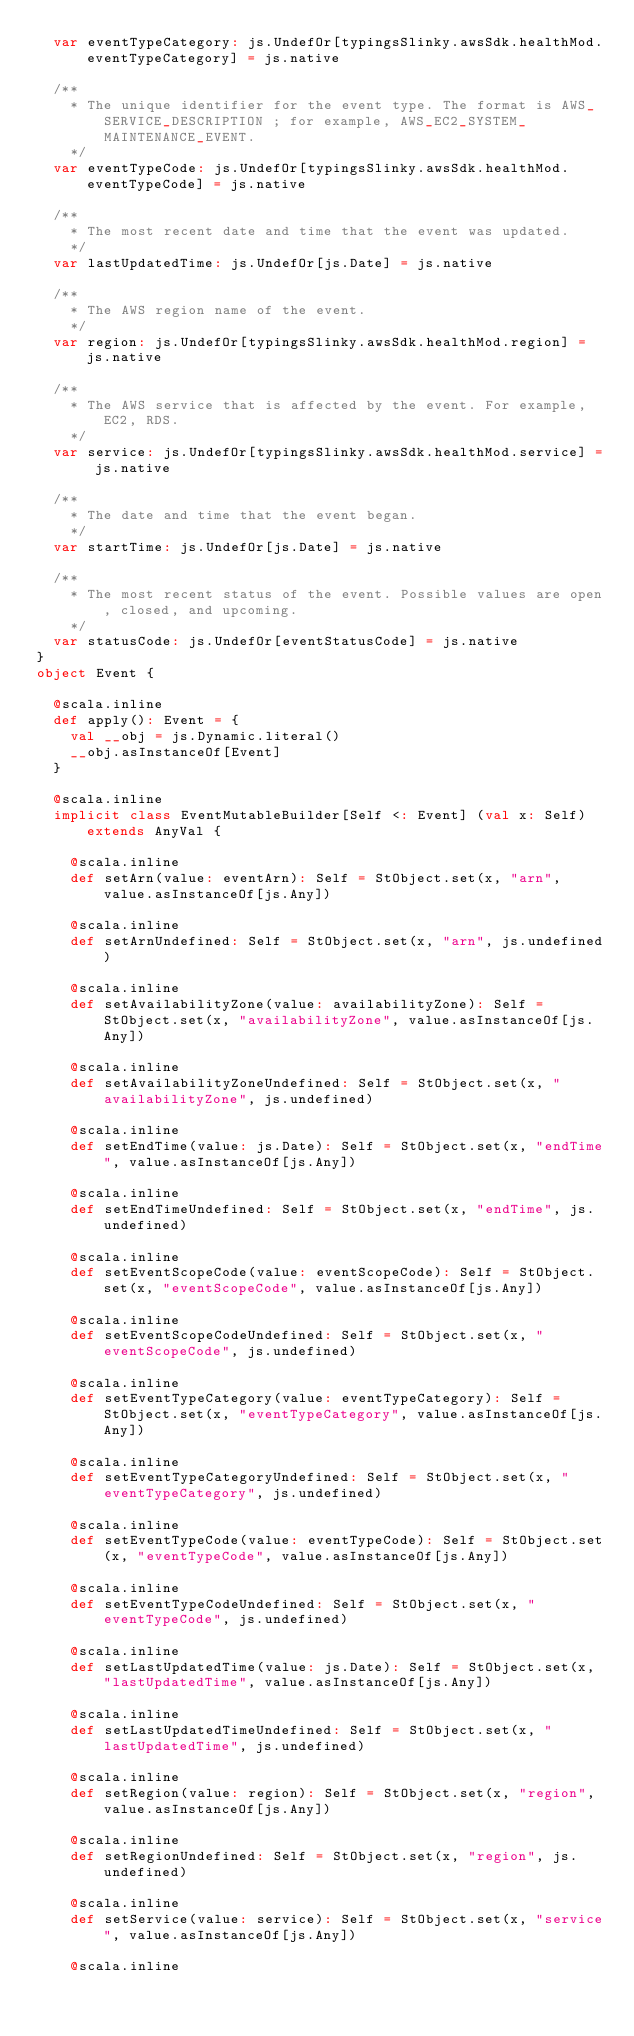<code> <loc_0><loc_0><loc_500><loc_500><_Scala_>  var eventTypeCategory: js.UndefOr[typingsSlinky.awsSdk.healthMod.eventTypeCategory] = js.native
  
  /**
    * The unique identifier for the event type. The format is AWS_SERVICE_DESCRIPTION ; for example, AWS_EC2_SYSTEM_MAINTENANCE_EVENT.
    */
  var eventTypeCode: js.UndefOr[typingsSlinky.awsSdk.healthMod.eventTypeCode] = js.native
  
  /**
    * The most recent date and time that the event was updated.
    */
  var lastUpdatedTime: js.UndefOr[js.Date] = js.native
  
  /**
    * The AWS region name of the event.
    */
  var region: js.UndefOr[typingsSlinky.awsSdk.healthMod.region] = js.native
  
  /**
    * The AWS service that is affected by the event. For example, EC2, RDS.
    */
  var service: js.UndefOr[typingsSlinky.awsSdk.healthMod.service] = js.native
  
  /**
    * The date and time that the event began.
    */
  var startTime: js.UndefOr[js.Date] = js.native
  
  /**
    * The most recent status of the event. Possible values are open, closed, and upcoming.
    */
  var statusCode: js.UndefOr[eventStatusCode] = js.native
}
object Event {
  
  @scala.inline
  def apply(): Event = {
    val __obj = js.Dynamic.literal()
    __obj.asInstanceOf[Event]
  }
  
  @scala.inline
  implicit class EventMutableBuilder[Self <: Event] (val x: Self) extends AnyVal {
    
    @scala.inline
    def setArn(value: eventArn): Self = StObject.set(x, "arn", value.asInstanceOf[js.Any])
    
    @scala.inline
    def setArnUndefined: Self = StObject.set(x, "arn", js.undefined)
    
    @scala.inline
    def setAvailabilityZone(value: availabilityZone): Self = StObject.set(x, "availabilityZone", value.asInstanceOf[js.Any])
    
    @scala.inline
    def setAvailabilityZoneUndefined: Self = StObject.set(x, "availabilityZone", js.undefined)
    
    @scala.inline
    def setEndTime(value: js.Date): Self = StObject.set(x, "endTime", value.asInstanceOf[js.Any])
    
    @scala.inline
    def setEndTimeUndefined: Self = StObject.set(x, "endTime", js.undefined)
    
    @scala.inline
    def setEventScopeCode(value: eventScopeCode): Self = StObject.set(x, "eventScopeCode", value.asInstanceOf[js.Any])
    
    @scala.inline
    def setEventScopeCodeUndefined: Self = StObject.set(x, "eventScopeCode", js.undefined)
    
    @scala.inline
    def setEventTypeCategory(value: eventTypeCategory): Self = StObject.set(x, "eventTypeCategory", value.asInstanceOf[js.Any])
    
    @scala.inline
    def setEventTypeCategoryUndefined: Self = StObject.set(x, "eventTypeCategory", js.undefined)
    
    @scala.inline
    def setEventTypeCode(value: eventTypeCode): Self = StObject.set(x, "eventTypeCode", value.asInstanceOf[js.Any])
    
    @scala.inline
    def setEventTypeCodeUndefined: Self = StObject.set(x, "eventTypeCode", js.undefined)
    
    @scala.inline
    def setLastUpdatedTime(value: js.Date): Self = StObject.set(x, "lastUpdatedTime", value.asInstanceOf[js.Any])
    
    @scala.inline
    def setLastUpdatedTimeUndefined: Self = StObject.set(x, "lastUpdatedTime", js.undefined)
    
    @scala.inline
    def setRegion(value: region): Self = StObject.set(x, "region", value.asInstanceOf[js.Any])
    
    @scala.inline
    def setRegionUndefined: Self = StObject.set(x, "region", js.undefined)
    
    @scala.inline
    def setService(value: service): Self = StObject.set(x, "service", value.asInstanceOf[js.Any])
    
    @scala.inline</code> 